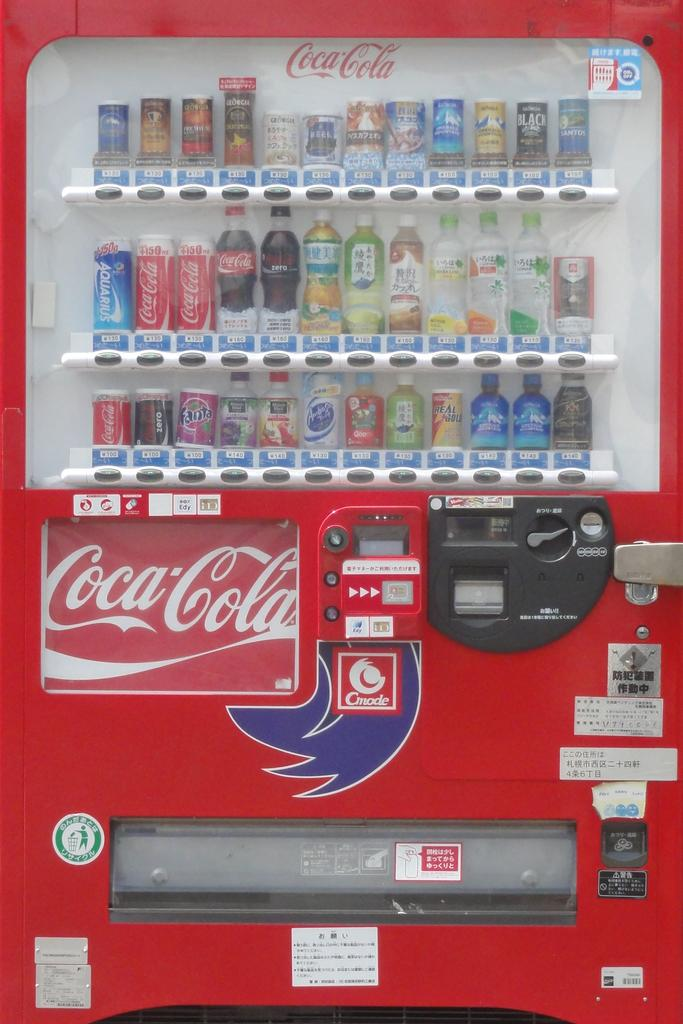<image>
Provide a brief description of the given image. A vending machine with Coca Cola branding displays both canned sodas and waters 